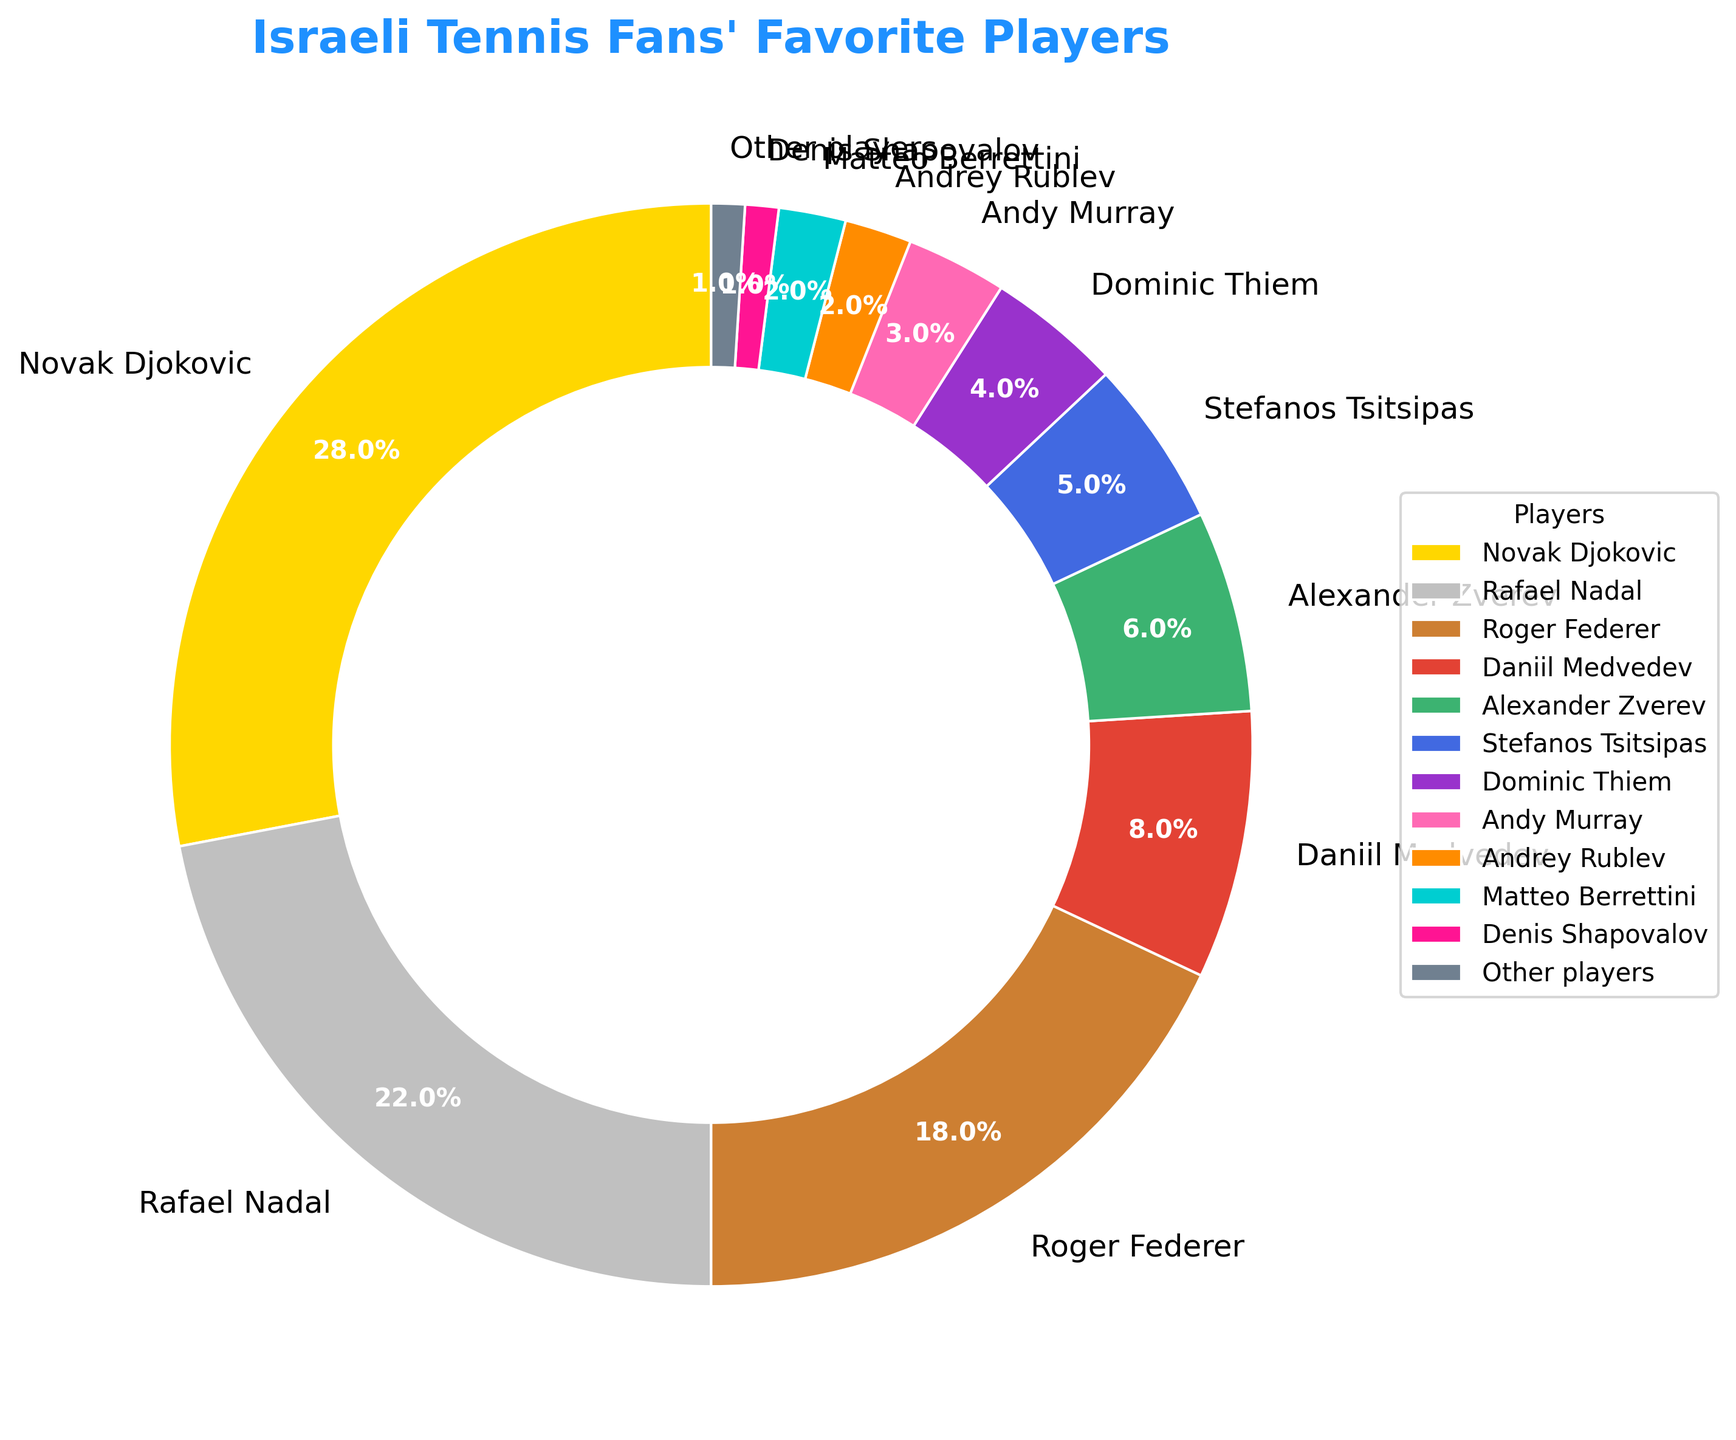Which player has the highest percentage of support from Israeli tennis fans? The player with the highest percentage is indicated by the largest wedge in the pie chart, which is labeled with the player name. Here, Novak Djokovic has the largest wedge with 28%.
Answer: Novak Djokovic What is the combined percentage of support for Rafael Nadal and Roger Federer? To find the combined percentage, sum the percentages of both Rafael Nadal (22%) and Roger Federer (18%). So, 22 + 18 = 40.
Answer: 40% Which two players have the smallest percentage of support and what is their combined percentage? The smallest wedges in the pie chart are labeled "Denis Shapovalov" and "Other players," each with 1%. Therefore, their combined percentage is 1 + 1 = 2.
Answer: Denis Shapovalov and Other players, 2% How much more popular is Novak Djokovic than Daniil Medvedev among Israeli tennis fans? To find how much more popular Djokovic is, subtract Medvedev's percentage (8%) from Djokovic's percentage (28%). So, 28 - 8 = 20.
Answer: 20% Is Stefanos Tsitsipas more or less popular than Alexander Zverev, and by how much? Compare the percentages of Tsitsipas (5%) and Zverev (6%). Subtract Tsitsipas's percentage from Zverev's: 6 - 5 = 1. Zverev is more popular by 1%.
Answer: Less, by 1% What percentage of Israeli tennis fans support players other than Djokovic, Nadal, and Federer? Calculate the total percentage of support for Djokovic, Nadal, and Federer, which is 28 + 22 + 18 = 68. Subtract this from 100%: 100 - 68 = 32.
Answer: 32% How many players have more than 10% of the support from Israeli tennis fans? Count the number of wedges with percentages greater than 10%. Djokovic (28%) and Nadal (22%) are the only two.
Answer: 2 Is the percentage of support for Dominic Thiem higher or lower than the combined support for Andrey Rublev and Matteo Berrettini? Add the percentages for Rublev (2%) and Berrettini (2%) first, which equals 4%. Thiem has 4%, making their support equal.
Answer: Equal What is the total percentage of support for the players who have less than 5% each? Add the percentages of Medvedev (8%), Zverev (6%), Tsitsipas (5%), Thiem (4%), Murray (3%), Rublev (2%), Berrettini (2%), and Shapovalov + Other players (1% each). This equals 8 + 6 + 5 + 4 + 3 + 2 + 2 + 2 = 32.
Answer: 32% Which player has exactly half the percentage of support as Rafael Nadal? Half of Nadal's support percentage (22%) is 11%. Looking at the plot, no player has exactly 11% support. Therefore, the answer is none.
Answer: None 